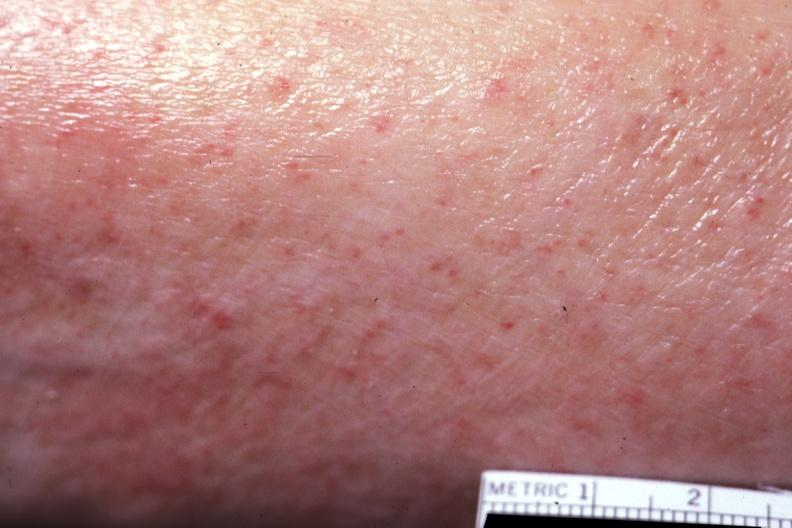what is present?
Answer the question using a single word or phrase. Petechial hemorrhages 